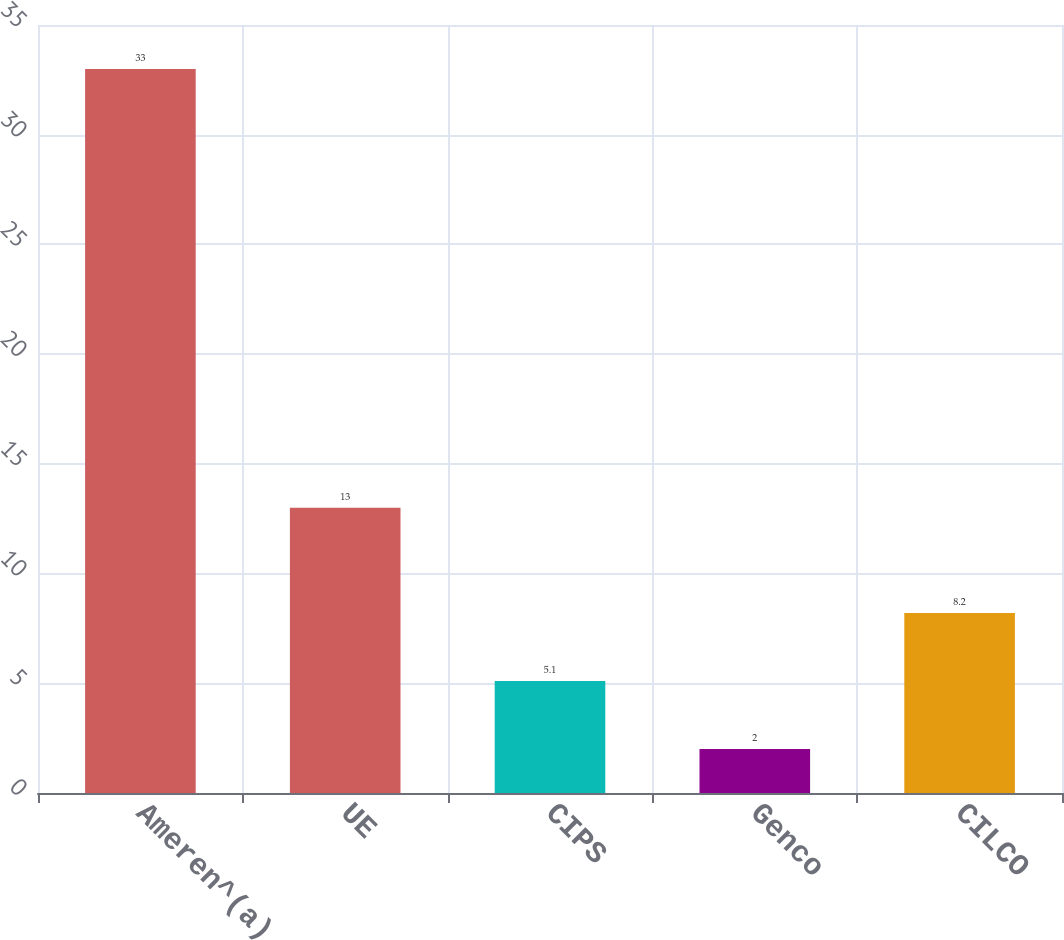<chart> <loc_0><loc_0><loc_500><loc_500><bar_chart><fcel>Ameren^(a)<fcel>UE<fcel>CIPS<fcel>Genco<fcel>CILCO<nl><fcel>33<fcel>13<fcel>5.1<fcel>2<fcel>8.2<nl></chart> 